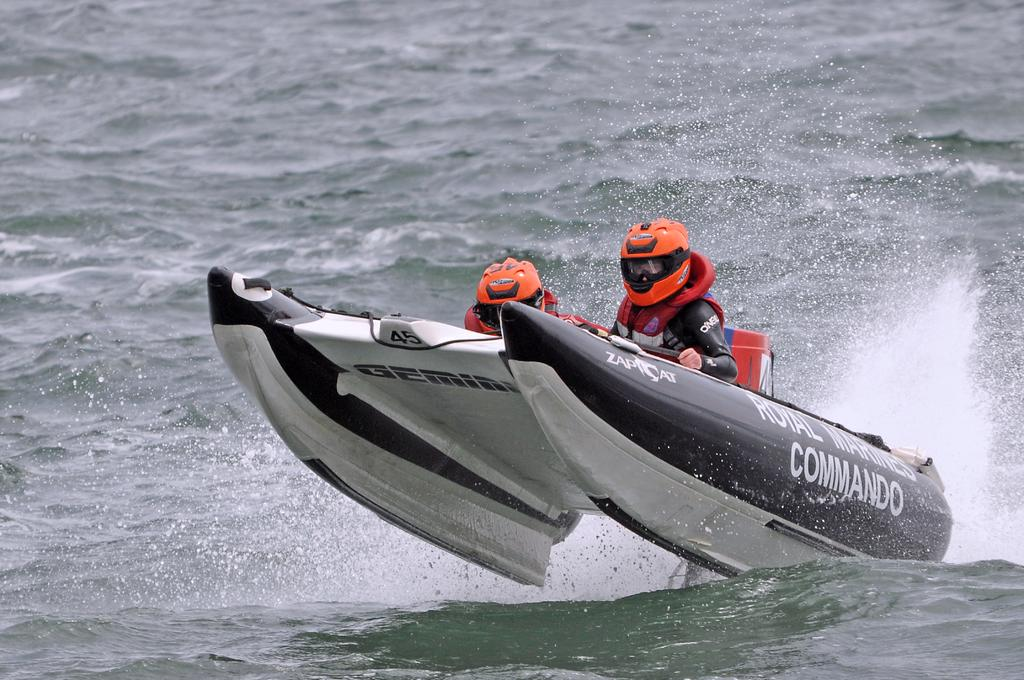<image>
Offer a succinct explanation of the picture presented. the word commando on the side of a little boat 